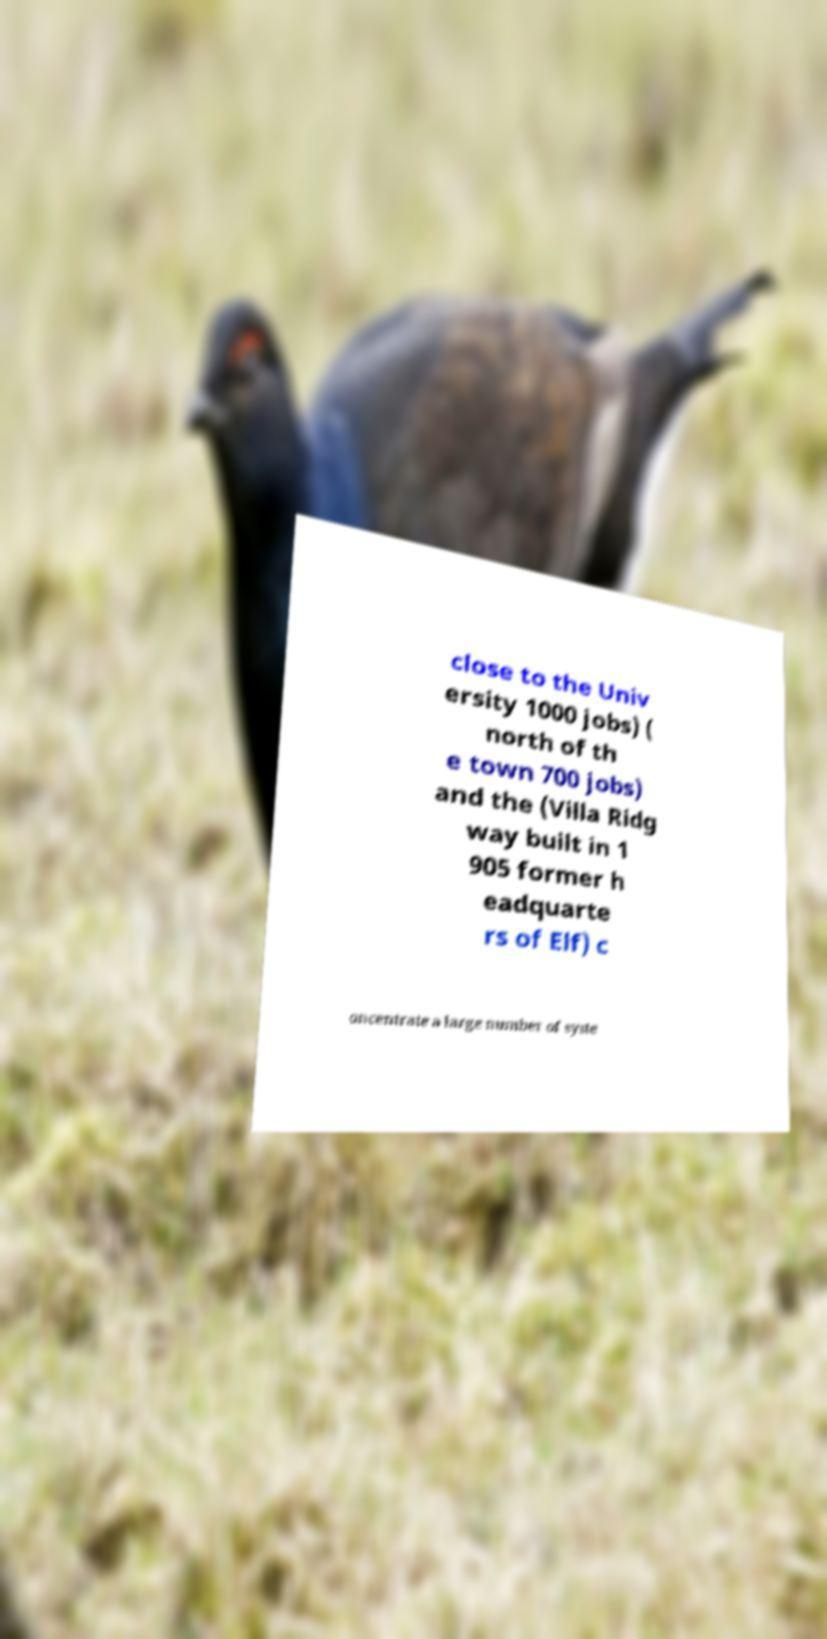What messages or text are displayed in this image? I need them in a readable, typed format. close to the Univ ersity 1000 jobs) ( north of th e town 700 jobs) and the (Villa Ridg way built in 1 905 former h eadquarte rs of Elf) c oncentrate a large number of syste 